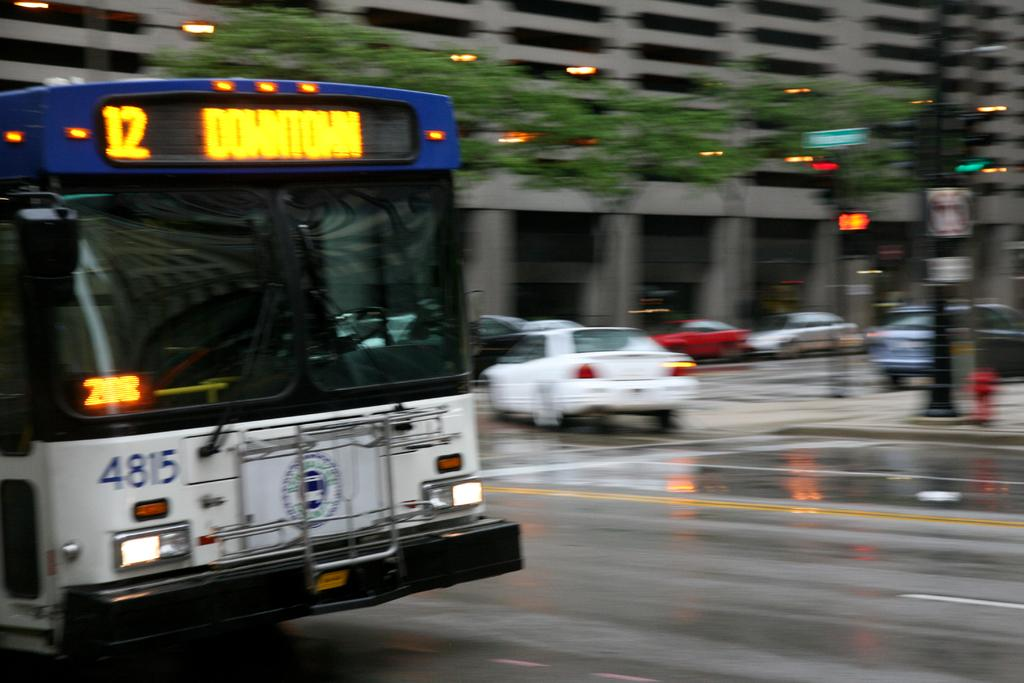What is the overall quality of the image? The image is blurred. What can be seen on the road in the image? There are vehicles on the road in the image. What feature of the vehicles is visible in the image? The headlights of the vehicles are visible. What type of natural elements can be seen in the image? There are trees in the image. What man-made structures are present in the image? There are poles and buildings in the image. Can you see a snail crawling on the coast in the image? There is no snail or coast present in the image; it features a blurred scene with vehicles, trees, poles, and buildings. What type of shop can be seen in the image? There is no shop present in the image. 